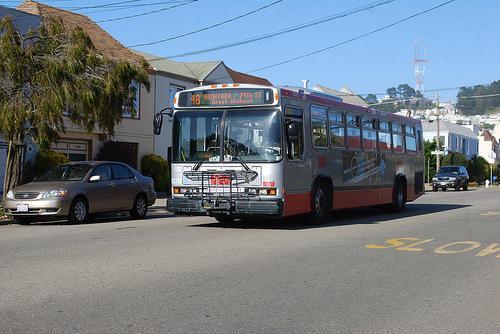How many buses are there?
Give a very brief answer. 1. How many vans are there?
Give a very brief answer. 1. 